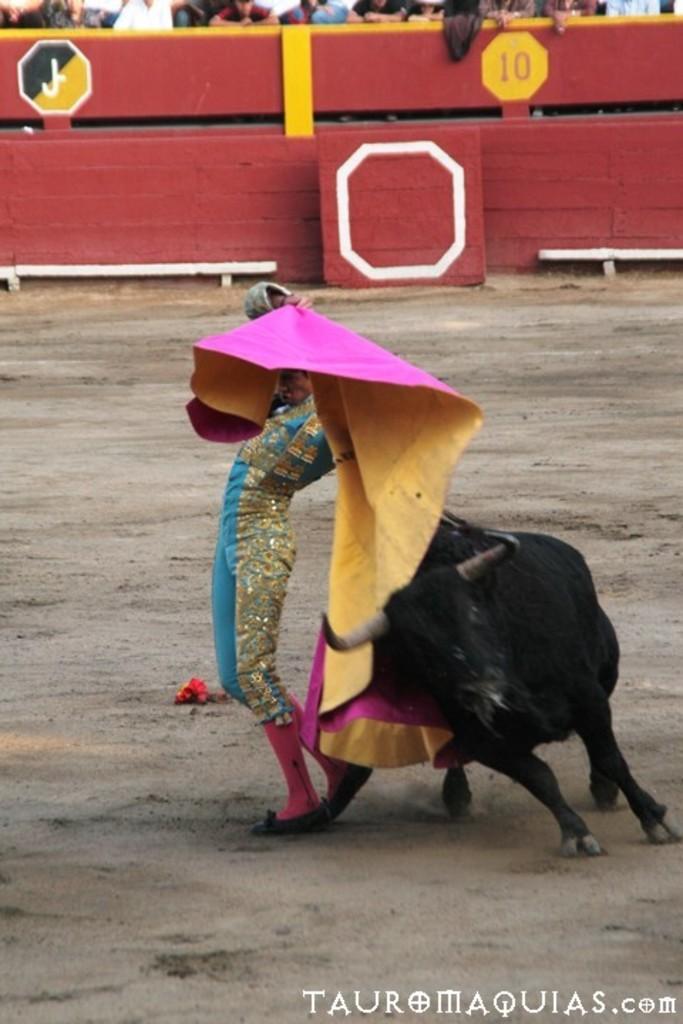Describe this image in one or two sentences. In the image I can see the bull fighting with a person and behind there is a fencing and also I can see some people to the other side of the fencing. 